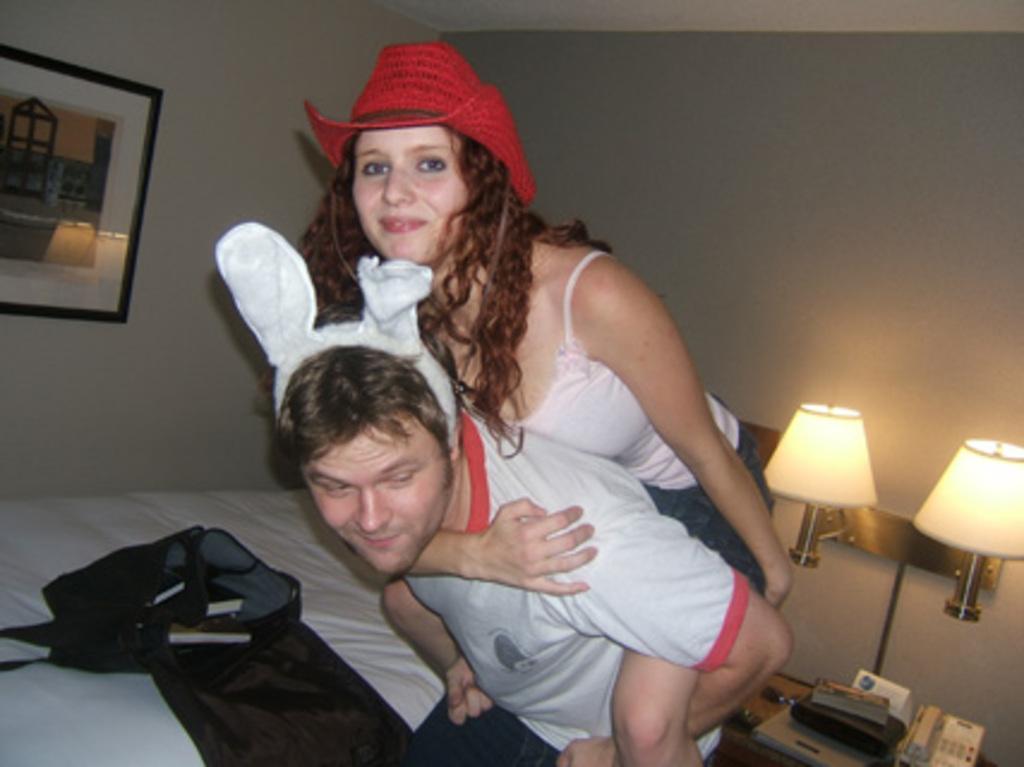Could you give a brief overview of what you see in this image? In this picture we can see a man and woman, she wore a cap and she is smiling, behind to them we can see few lights, telephone and other things on the table, and also we can see a frame on the wall. 